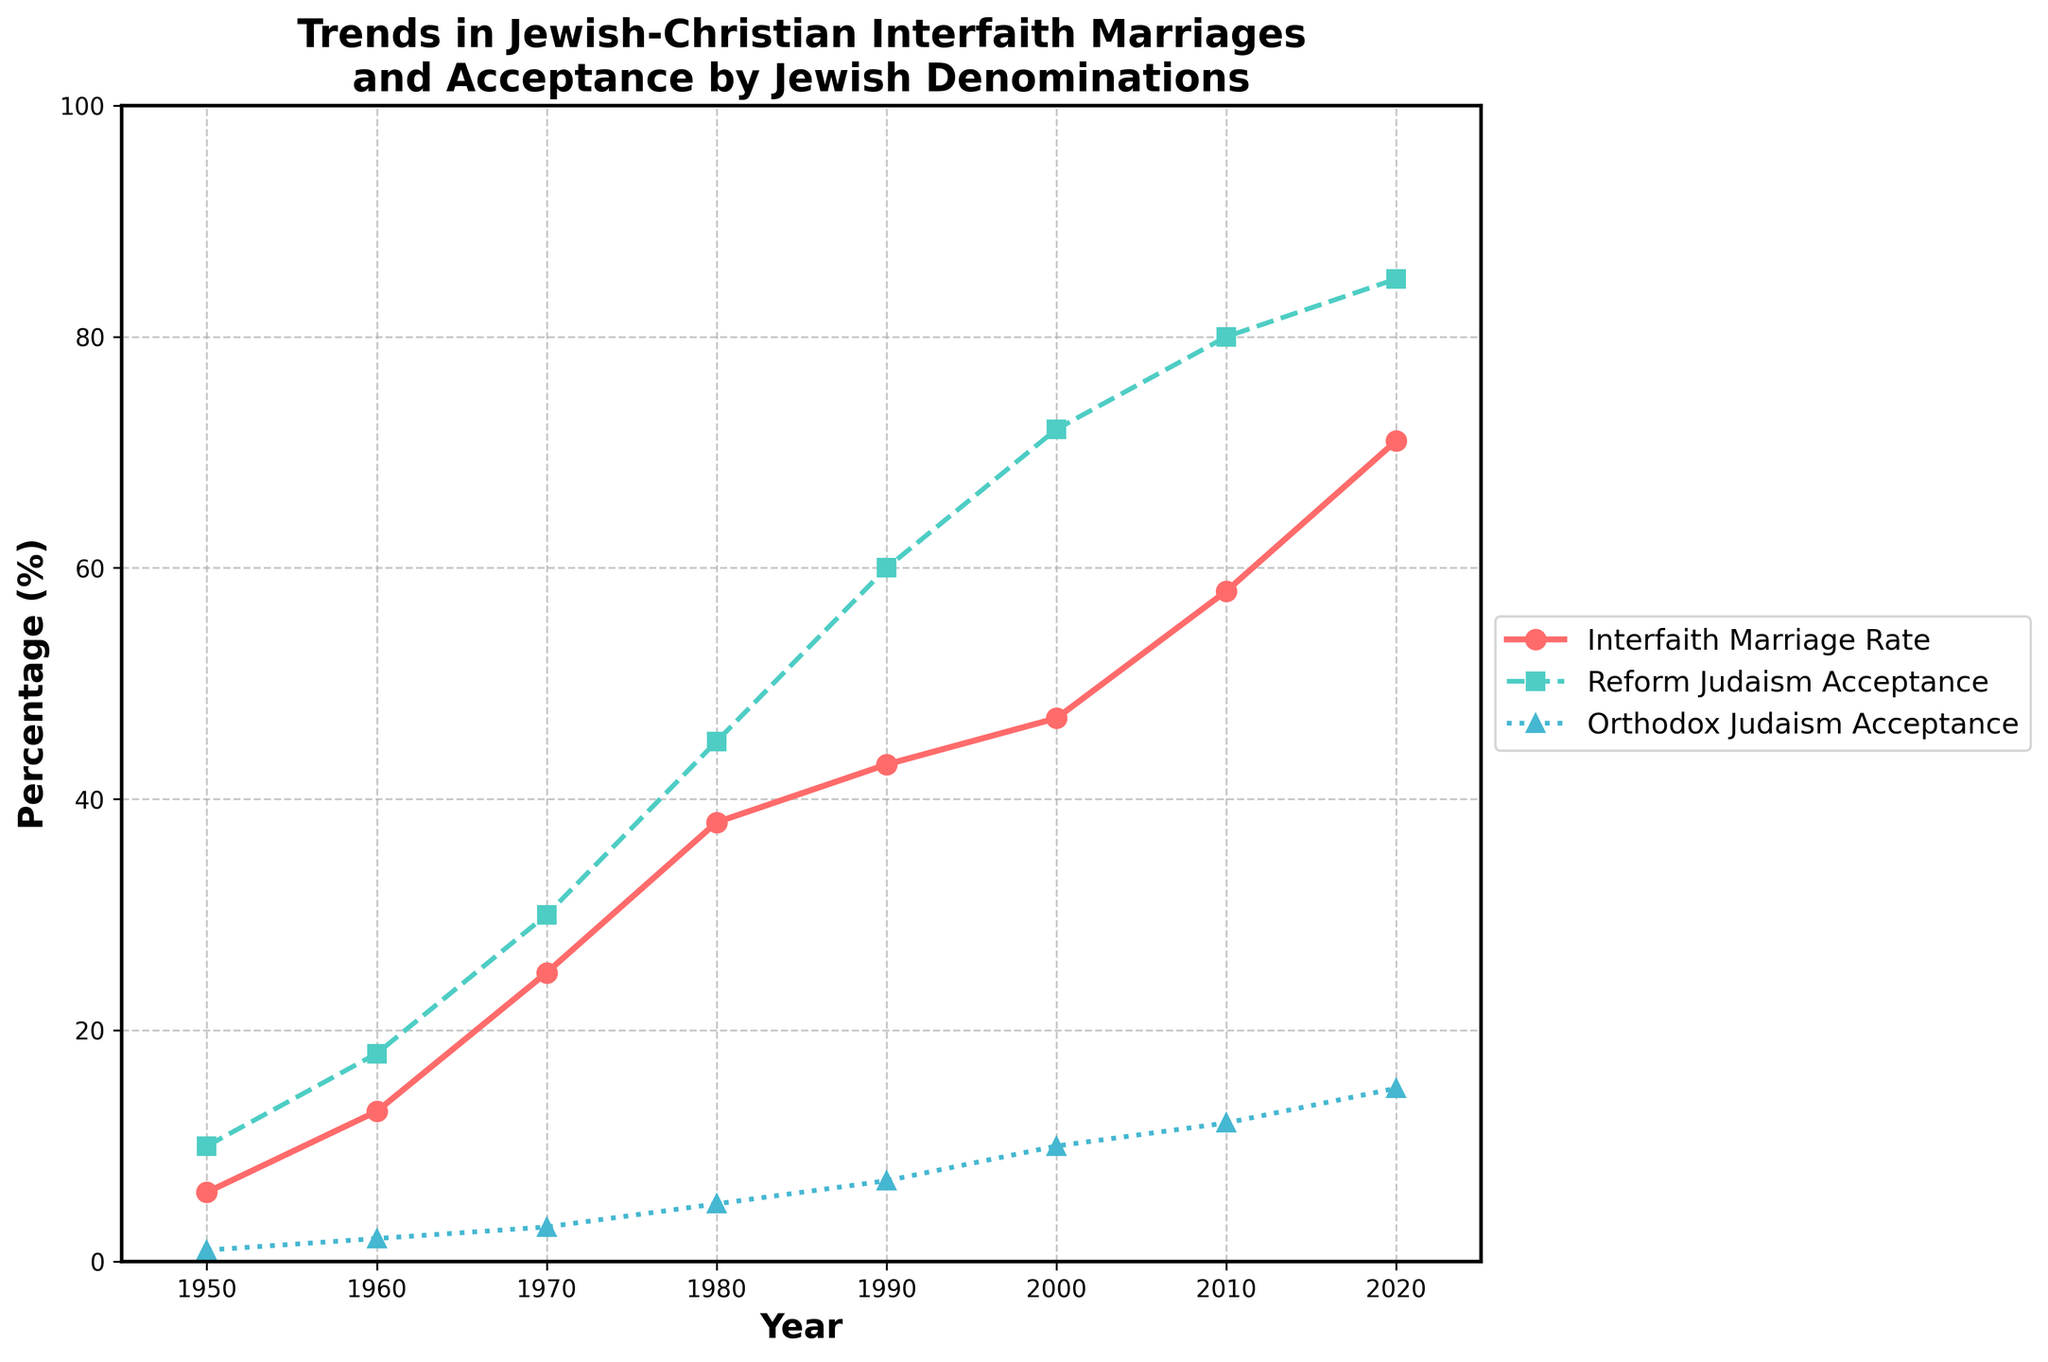What was the interfaith marriage rate in 1950? The data point corresponding to the year 1950 shows that the Jewish-Christian interfaith marriage rate was 6%.
Answer: 6% How did the acceptance of interfaith marriages by Orthodox Judaism change from 1950 to 2020? Examine the Orthodox Judaism Acceptance (%) line. In 1950, it was 1%, and in 2020, it increased to 15%. Thus, the change was 15% - 1% = 14%.
Answer: 14% Which year saw the highest interfaith marriage rate and what was it? By looking at the Jewish-Christian Interfaith Marriage Rate (%) line, the highest point is in 2020, with a rate of 71%.
Answer: 2020, 71% In 1980, how did the acceptance of interfaith marriages by Reform Judaism compare to Orthodox Judaism? In 1980, the acceptance by Reform Judaism was 45%, and for Orthodox Judaism, it was 5%. Reform Judaism's acceptance was greater.
Answer: Reform Judaism: 45%, Orthodox Judaism: 5% What was the annual increase in interfaith marriage rates between 1970 and 1980? The interfaith marriage rate in 1970 was 25%, and in 1980, it was 38%. The difference over the 10 years is 38% - 25% = 13%, so the annual increase was 13% / 10 years = 1.3%.
Answer: 1.3% Which denomination had a steeper increase in acceptance rates from 2000 to 2020? From 2000 to 2020, Reform Judaism acceptance increased from 72% to 85% (13%), while Orthodox Judaism acceptance increased from 10% to 15% (5%). Reform Judaism had a steeper increase.
Answer: Reform Judaism Has the interfaith marriage rate ever decreased over the years shown? Observing the Jewish-Christian Interfaith Marriage Rate (%) line, the rate steadily increased without any decline over the years from 1950 to 2020.
Answer: No What are the last two years in which the interfaith marriage rate increased by more than 10% per decade? From 2000 to 2010, the rate increased by 11% (47% to 58%), and from 2010 to 2020, it increased by 13% (58% to 71%). These are the last two decades with an increase greater than 10%.
Answer: 2000-2010, 2010-2020 What is the difference in interfaith marriage rates between 1960 and 2020? The interfaith marriage rate in 1960 was 13%, and in 2020 it was 71%. The difference is 71% - 13% = 58%.
Answer: 58% Compare the acceptance rates of Reform and Orthodox Judaism in 1990. In 1990, the acceptance rate of Reform Judaism was 60%, whereas for Orthodox Judaism, it was 7%. Reform Judaism's acceptance rate was significantly higher.
Answer: Reform Judaism: 60%, Orthodox Judaism: 7% 